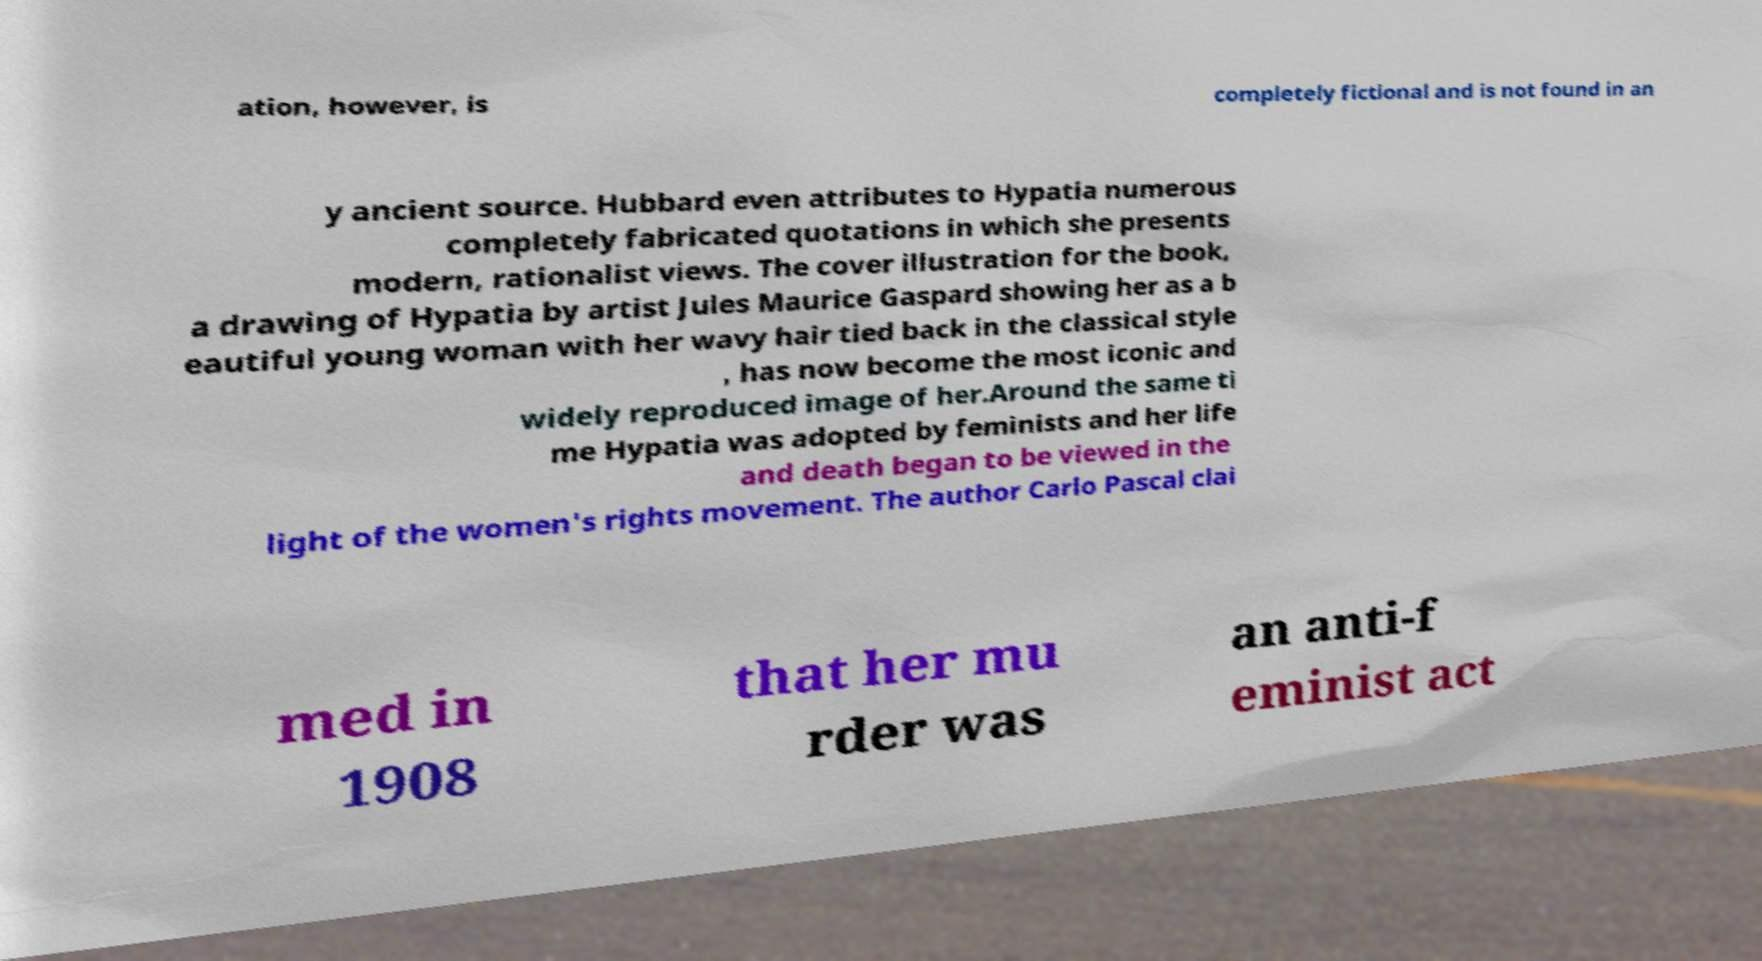Could you assist in decoding the text presented in this image and type it out clearly? ation, however, is completely fictional and is not found in an y ancient source. Hubbard even attributes to Hypatia numerous completely fabricated quotations in which she presents modern, rationalist views. The cover illustration for the book, a drawing of Hypatia by artist Jules Maurice Gaspard showing her as a b eautiful young woman with her wavy hair tied back in the classical style , has now become the most iconic and widely reproduced image of her.Around the same ti me Hypatia was adopted by feminists and her life and death began to be viewed in the light of the women's rights movement. The author Carlo Pascal clai med in 1908 that her mu rder was an anti-f eminist act 